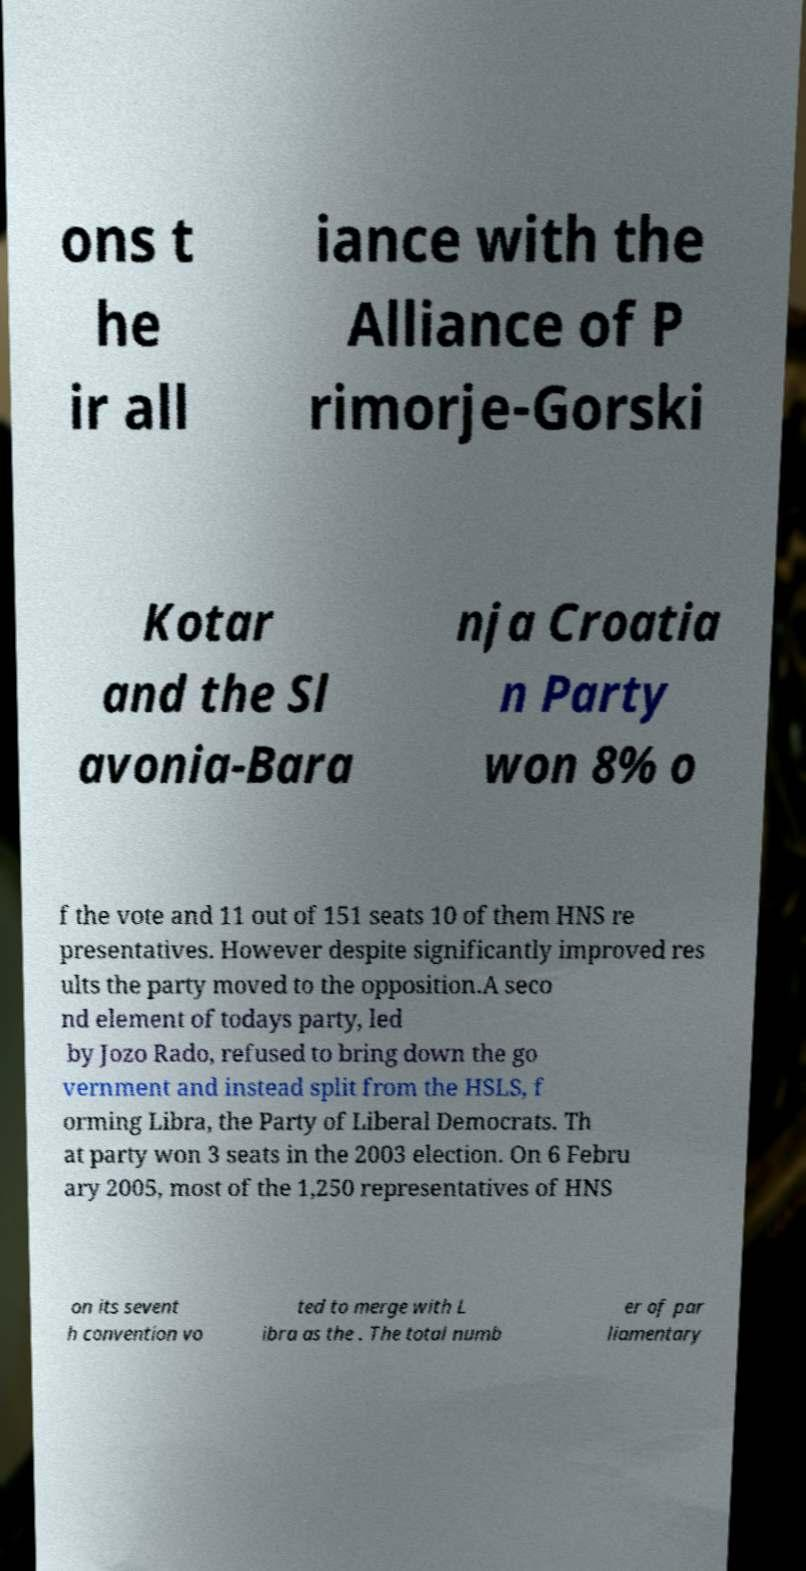Could you extract and type out the text from this image? ons t he ir all iance with the Alliance of P rimorje-Gorski Kotar and the Sl avonia-Bara nja Croatia n Party won 8% o f the vote and 11 out of 151 seats 10 of them HNS re presentatives. However despite significantly improved res ults the party moved to the opposition.A seco nd element of todays party, led by Jozo Rado, refused to bring down the go vernment and instead split from the HSLS, f orming Libra, the Party of Liberal Democrats. Th at party won 3 seats in the 2003 election. On 6 Febru ary 2005, most of the 1,250 representatives of HNS on its sevent h convention vo ted to merge with L ibra as the . The total numb er of par liamentary 